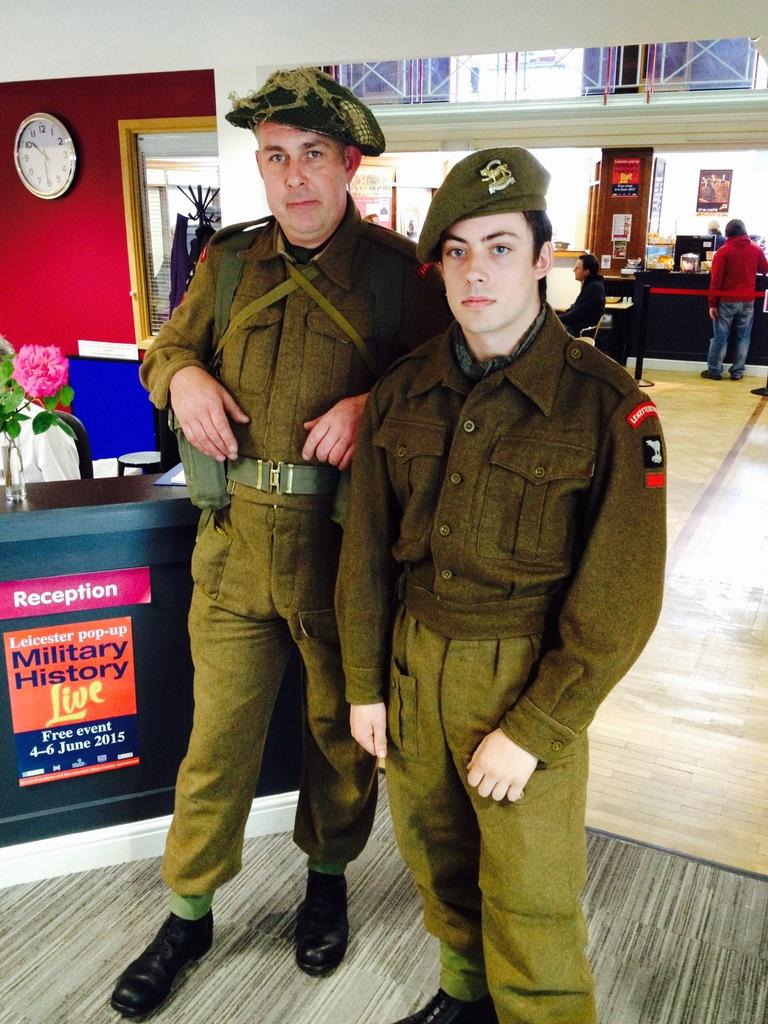How many people are in the image? There are two men standing in the image. What are the men wearing on their heads? The men are wearing hats. What can be seen on the wall in the image? There is a clock on the wall. What architectural feature is present in the image? There is a door in the image. What type of store can be seen in the image? There is no store present in the image. What rule is being enforced by the men in the image? There is no indication of any rule being enforced in the image. 